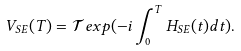Convert formula to latex. <formula><loc_0><loc_0><loc_500><loc_500>V _ { S E } ( T ) = \mathcal { T } e x p ( - i \int _ { 0 } ^ { T } H _ { S E } ( t ) d t ) .</formula> 